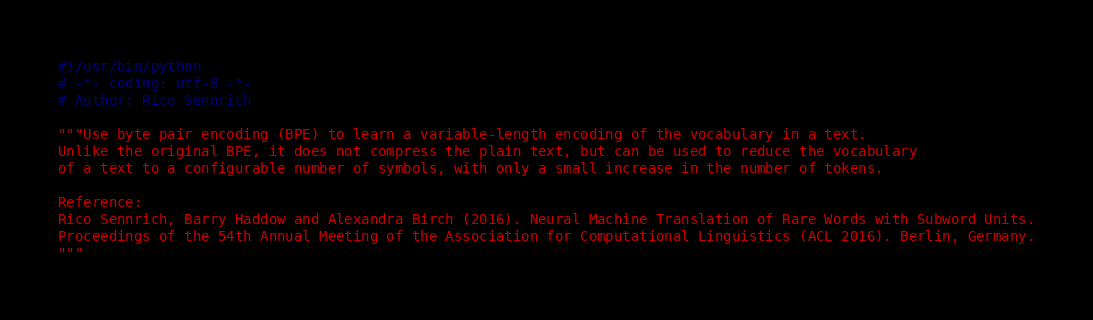<code> <loc_0><loc_0><loc_500><loc_500><_Python_>#!/usr/bin/python
# -*- coding: utf-8 -*-
# Author: Rico Sennrich

"""Use byte pair encoding (BPE) to learn a variable-length encoding of the vocabulary in a text.
Unlike the original BPE, it does not compress the plain text, but can be used to reduce the vocabulary
of a text to a configurable number of symbols, with only a small increase in the number of tokens.

Reference:
Rico Sennrich, Barry Haddow and Alexandra Birch (2016). Neural Machine Translation of Rare Words with Subword Units.
Proceedings of the 54th Annual Meeting of the Association for Computational Linguistics (ACL 2016). Berlin, Germany.
"""
</code> 